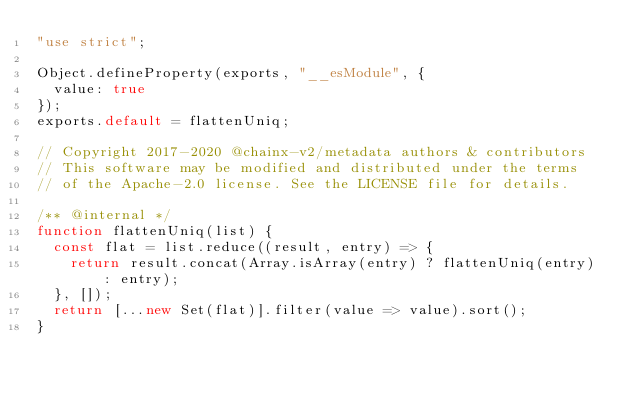Convert code to text. <code><loc_0><loc_0><loc_500><loc_500><_JavaScript_>"use strict";

Object.defineProperty(exports, "__esModule", {
  value: true
});
exports.default = flattenUniq;

// Copyright 2017-2020 @chainx-v2/metadata authors & contributors
// This software may be modified and distributed under the terms
// of the Apache-2.0 license. See the LICENSE file for details.

/** @internal */
function flattenUniq(list) {
  const flat = list.reduce((result, entry) => {
    return result.concat(Array.isArray(entry) ? flattenUniq(entry) : entry);
  }, []);
  return [...new Set(flat)].filter(value => value).sort();
}</code> 